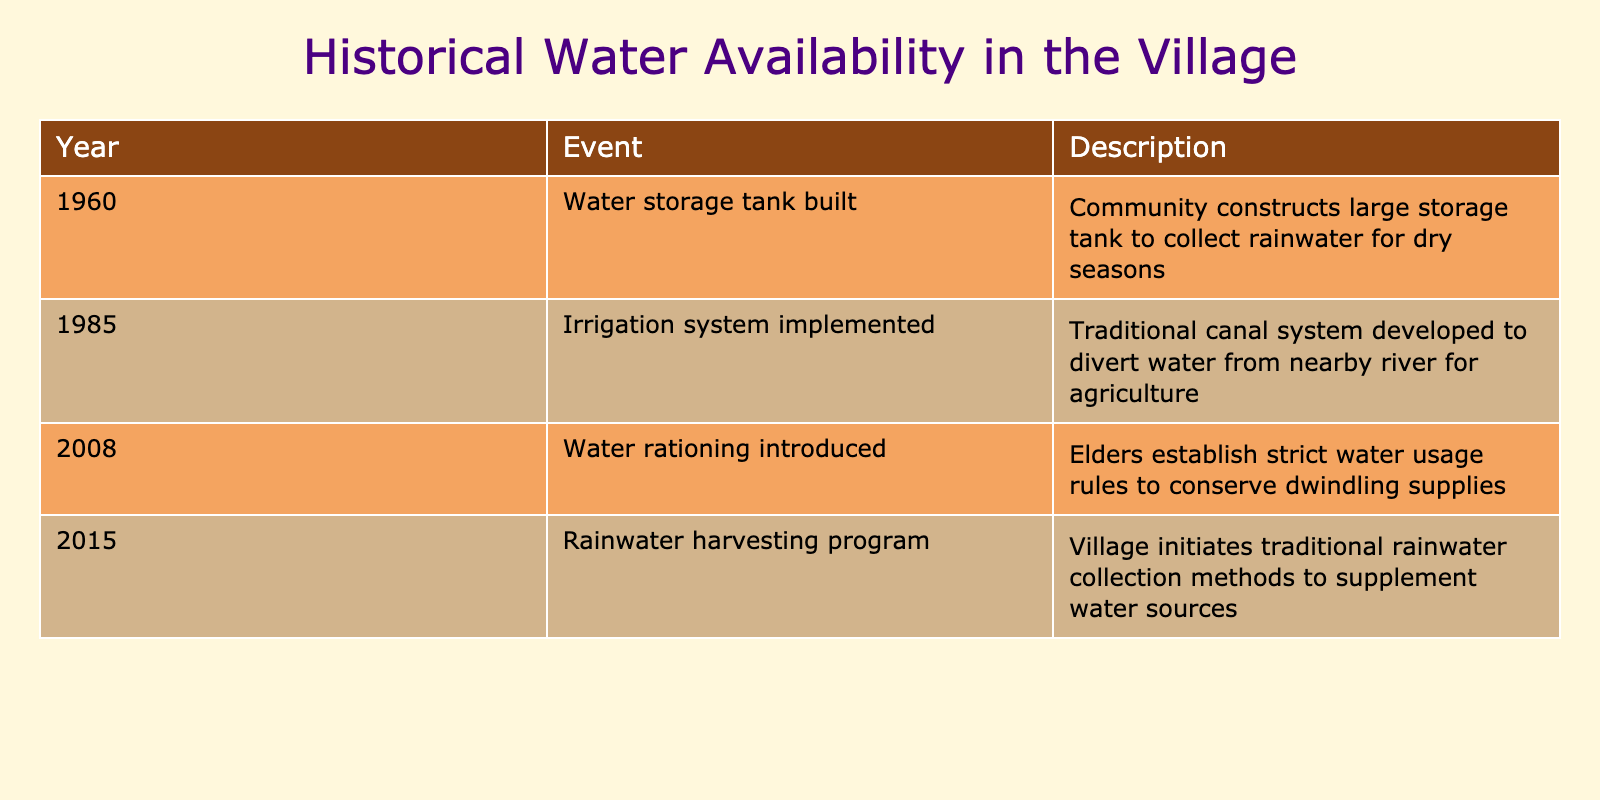What event marked the beginning of water-related infrastructure in the village? The table indicates that the construction of a large storage tank in 1960 was the first significant event related to water infrastructure. This is the oldest event listed, signaling the community's early efforts to manage water availability.
Answer: Water storage tank built In which year was water rationing introduced in the village? According to the table, water rationing was established in 2008. This event is explicitly stated in the corresponding row along with its description, making it easy to locate.
Answer: 2008 How many years passed between the construction of the water storage tank and the implementation of the irrigation system? The water storage tank was built in 1960, and the irrigation system was implemented in 1985. The difference between these two years is 1985 - 1960 = 25 years. This calculation is derived from simply subtracting the earlier year from the later one.
Answer: 25 years Did the village implement any water conservation methods before 2008? Yes, the table shows that the community started implementing an irrigation system in 1985, which is a water conservation method that diverts water for agricultural purposes. Hence, a water-saving method was indeed in place prior to 2008.
Answer: Yes What significant change in water management occurred between 2015 and prior events? In 2015, a rainwater harvesting program was initiated, which differed from the previous events focused on constructing infrastructure and rationing measures. This program represents a shift towards utilizing traditional methods for sourcing water rather than relying solely on infrastructure. The addition of this method in 2015 is the only one focused on rainwater collection rather than storage or restriction.
Answer: Shift to rainwater harvesting program How many key events related to water management are noted in the table? By counting the entries in the table, we find that there are five distinct events: the construction of the water storage tank in 1960, the implementation of the irrigation system in 1985, the introduction of water rationing in 2008, and the initiation of the rainwater harvesting program in 2015. Thus, we conclude that there are four major events listed.
Answer: Four events 